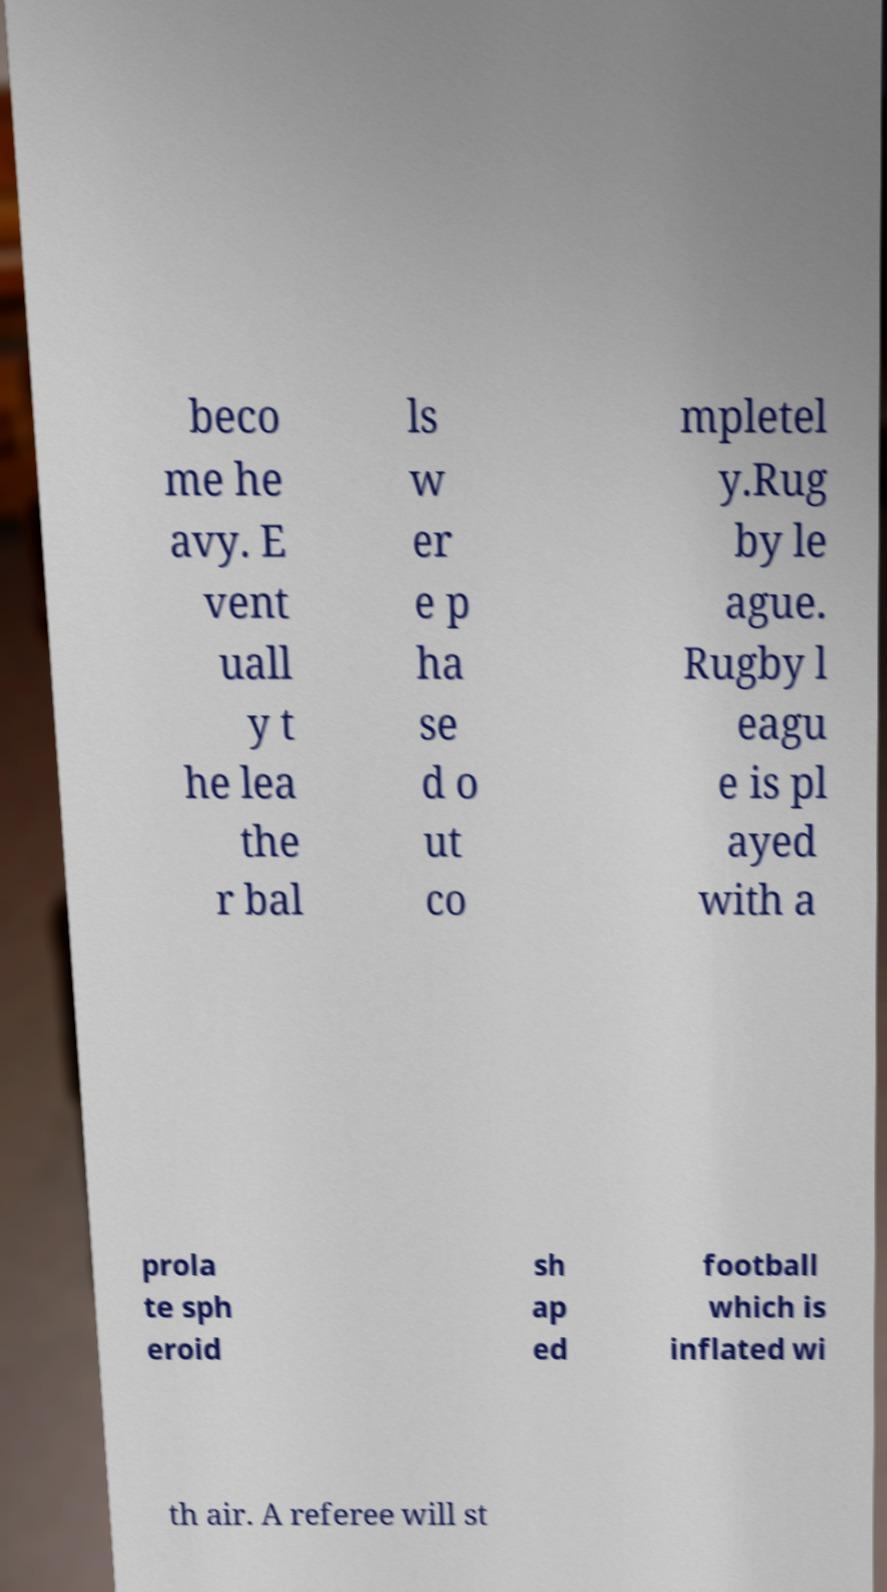For documentation purposes, I need the text within this image transcribed. Could you provide that? beco me he avy. E vent uall y t he lea the r bal ls w er e p ha se d o ut co mpletel y.Rug by le ague. Rugby l eagu e is pl ayed with a prola te sph eroid sh ap ed football which is inflated wi th air. A referee will st 